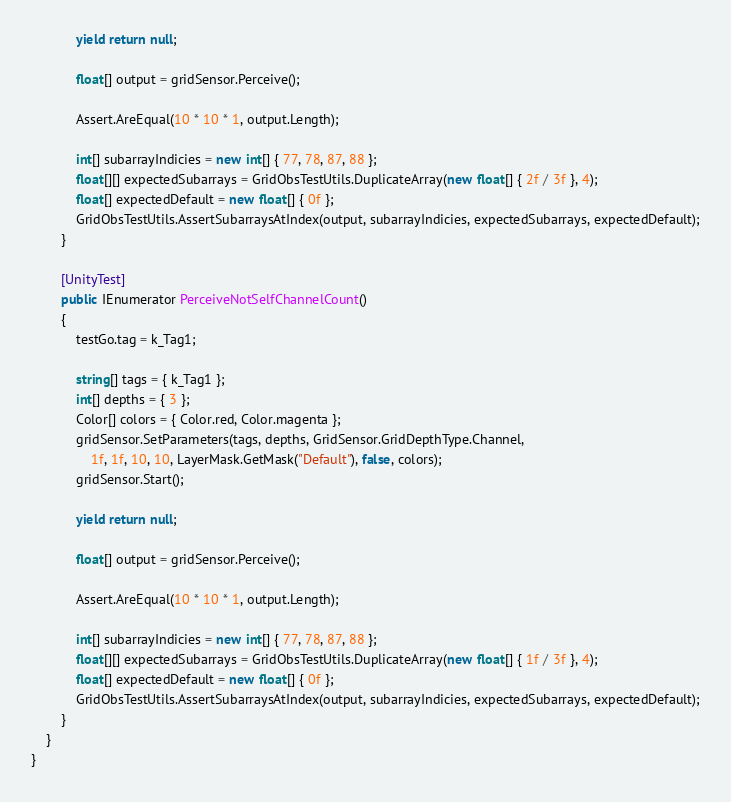<code> <loc_0><loc_0><loc_500><loc_500><_C#_>            yield return null;

            float[] output = gridSensor.Perceive();

            Assert.AreEqual(10 * 10 * 1, output.Length);

            int[] subarrayIndicies = new int[] { 77, 78, 87, 88 };
            float[][] expectedSubarrays = GridObsTestUtils.DuplicateArray(new float[] { 2f / 3f }, 4);
            float[] expectedDefault = new float[] { 0f };
            GridObsTestUtils.AssertSubarraysAtIndex(output, subarrayIndicies, expectedSubarrays, expectedDefault);
        }

        [UnityTest]
        public IEnumerator PerceiveNotSelfChannelCount()
        {
            testGo.tag = k_Tag1;

            string[] tags = { k_Tag1 };
            int[] depths = { 3 };
            Color[] colors = { Color.red, Color.magenta };
            gridSensor.SetParameters(tags, depths, GridSensor.GridDepthType.Channel,
                1f, 1f, 10, 10, LayerMask.GetMask("Default"), false, colors);
            gridSensor.Start();

            yield return null;

            float[] output = gridSensor.Perceive();

            Assert.AreEqual(10 * 10 * 1, output.Length);

            int[] subarrayIndicies = new int[] { 77, 78, 87, 88 };
            float[][] expectedSubarrays = GridObsTestUtils.DuplicateArray(new float[] { 1f / 3f }, 4);
            float[] expectedDefault = new float[] { 0f };
            GridObsTestUtils.AssertSubarraysAtIndex(output, subarrayIndicies, expectedSubarrays, expectedDefault);
        }
    }
}
</code> 